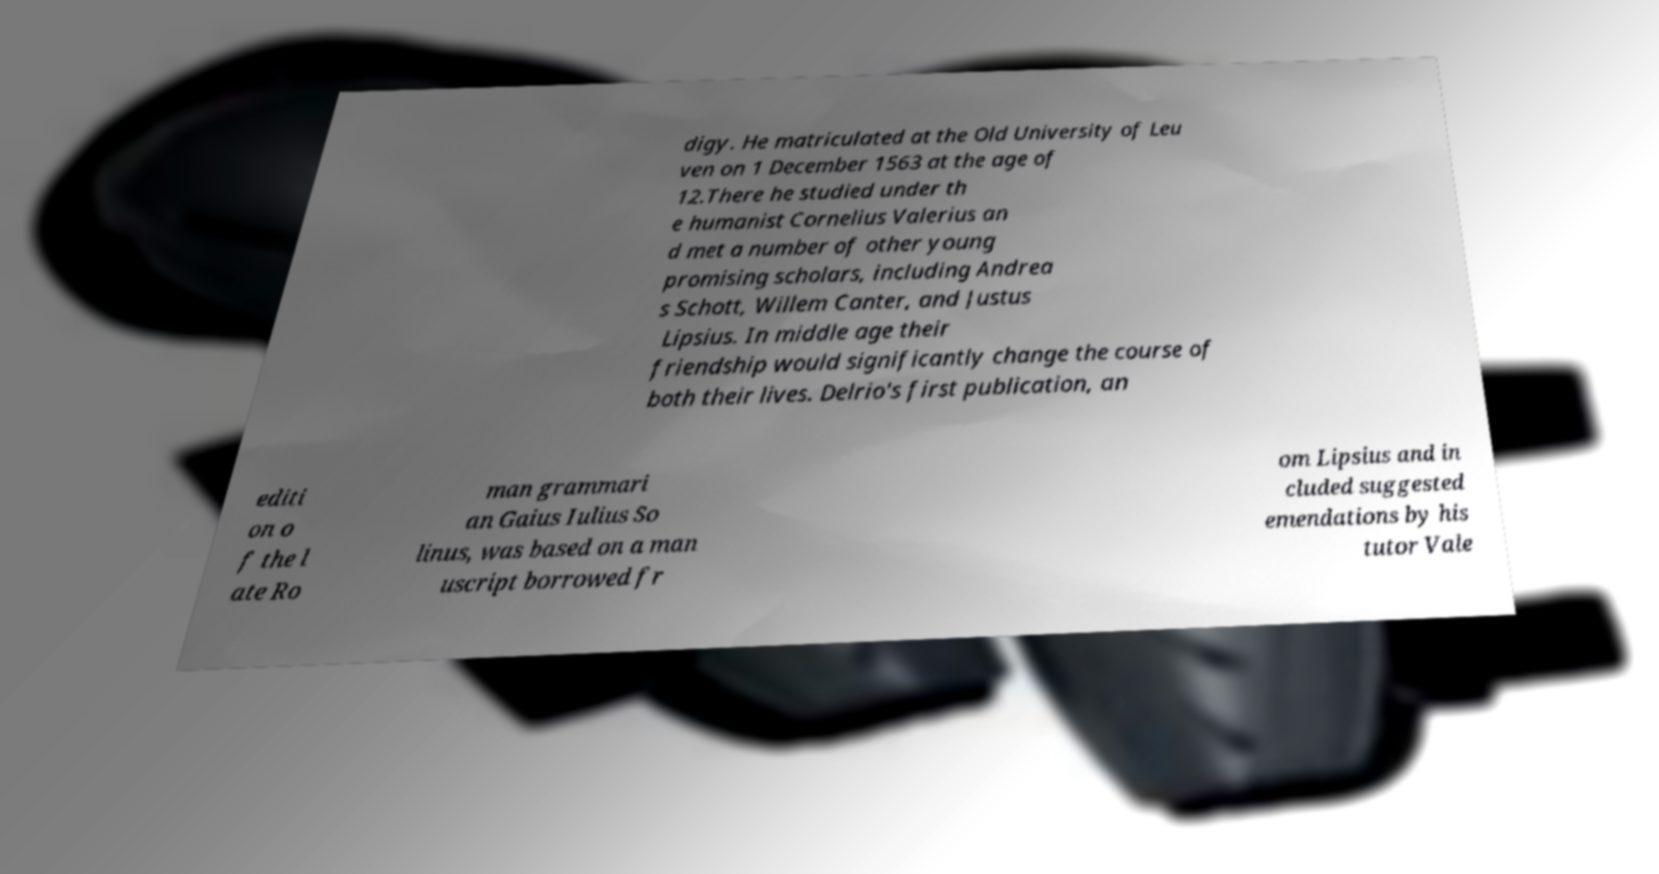Can you accurately transcribe the text from the provided image for me? digy. He matriculated at the Old University of Leu ven on 1 December 1563 at the age of 12.There he studied under th e humanist Cornelius Valerius an d met a number of other young promising scholars, including Andrea s Schott, Willem Canter, and Justus Lipsius. In middle age their friendship would significantly change the course of both their lives. Delrio's first publication, an editi on o f the l ate Ro man grammari an Gaius Iulius So linus, was based on a man uscript borrowed fr om Lipsius and in cluded suggested emendations by his tutor Vale 